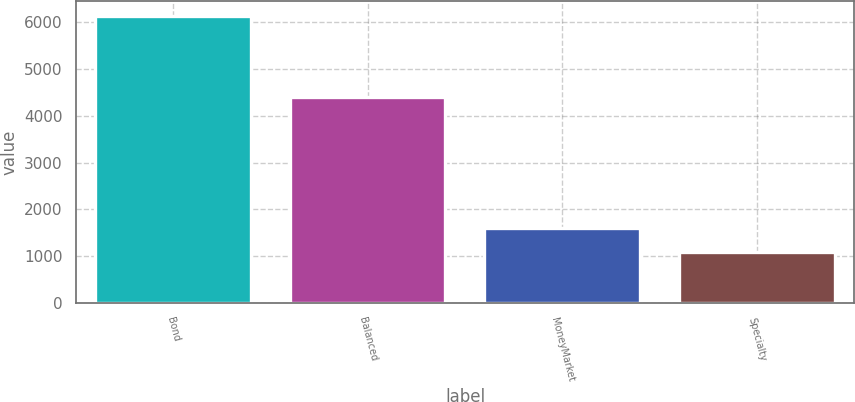Convert chart to OTSL. <chart><loc_0><loc_0><loc_500><loc_500><bar_chart><fcel>Bond<fcel>Balanced<fcel>MoneyMarket<fcel>Specialty<nl><fcel>6139<fcel>4403<fcel>1593.1<fcel>1088<nl></chart> 